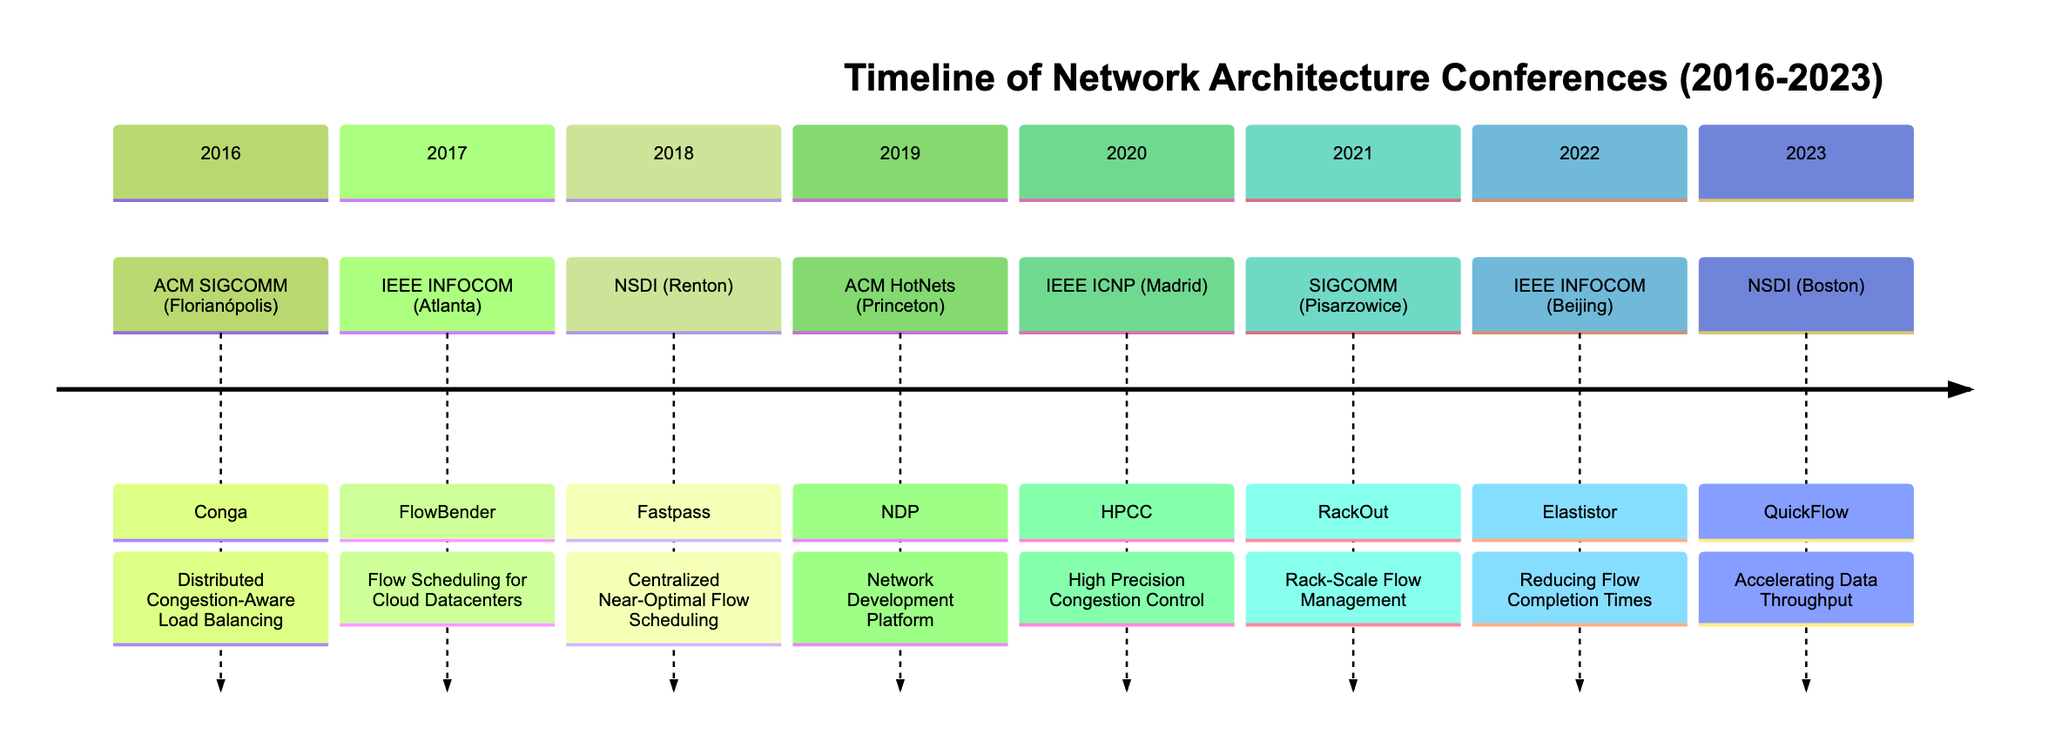What conference was held in 2016? The diagram indicates that the ACM SIGCOMM conference took place in 2016. This can be identified by looking at the first section of the timeline, which lists the year 2016 and the associated conference.
Answer: ACM SIGCOMM What was highlighted during the IEEE INFOCOM conference in 2022? The diagram shows that the highlight for the IEEE INFOCOM conference in 2022 was "Enhanced Algorithms for Elastistor: Reducing Flow Completion Times in Dynamic Networks." This information is directly taken from the 2022 section of the timeline.
Answer: Enhanced Algorithms for Elastistor: Reducing Flow Completion Times in Dynamic Networks How many conferences were held in even years (2016, 2018, 2020, 2022)? By counting the specified years in the timeline, there are four conferences listed for the even years: ACM SIGCOMM in 2016, NSDI in 2018, IEEE ICNP in 2020, and IEEE INFOCOM in 2022. Each conference corresponds to an even year shown in the timeline.
Answer: 4 Which conference took place in the year 2019? The timeline indicates that the ACM HotNets conference was held in 2019. This can be confirmed by locating the section labeled 2019 in the timeline, which specifically mentions this conference.
Answer: ACM HotNets What is the significance of the term "QuickFlow" introduced in 2023? According to the timeline, "QuickFlow" was introduced as a method to "Accelerate Data Throughput in Modern Datacenter Architectures" during the NSDI conference in 2023. This information can be found in the section for the year 2023 in the diagram.
Answer: Accelerating Data Throughput in Modern Datacenter Architectures Which location hosted the SIGCOMM conference in 2021? The diagram indicates that the SIGCOMM conference in 2021 was held in Pisarzowice, Poland, as specified in the section for that year in the timeline.
Answer: Pisarzowice, Poland What advancement was presented at ACM HotNets in 2019? The diagram highlights that the presentation of NDP, which stands for "Network Development Platform for Synthetic Workload Evaluation in Datacenters," occurred during the ACM HotNets conference in 2019. This information can be extracted from the relevant section on the timeline.
Answer: NDP: Network Development Platform How does the highlight of the 2021 SIGCOMM conference compare to that of the 2017 IEEE INFOCOM conference? The SIGCOMM conference in 2021 focused on "RackOut: Boosting Network Architectures with Rack-Scale Flow Management," while the IEEE INFOCOM conference in 2017 highlighted "FlowBender: Flow Scheduling for Ethernet-based Cloud Datacenters." Comparing both highlights reveals different themes, with one emphasizing rack-scale management and the other focusing on cloud datacenter flow scheduling.
Answer: RackOut vs. FlowBender What trend can be observed about the advancements in flow algorithms from 2016 to 2023? Analyzing the timeline reveals a continuous evolution in flow algorithms, with each conference showcasing improvements in congestion management, scheduling techniques, and throughput enhancements. This trend signifies the growing complexity and need for efficiency in data center management over the years.
Answer: Continuous evolution 